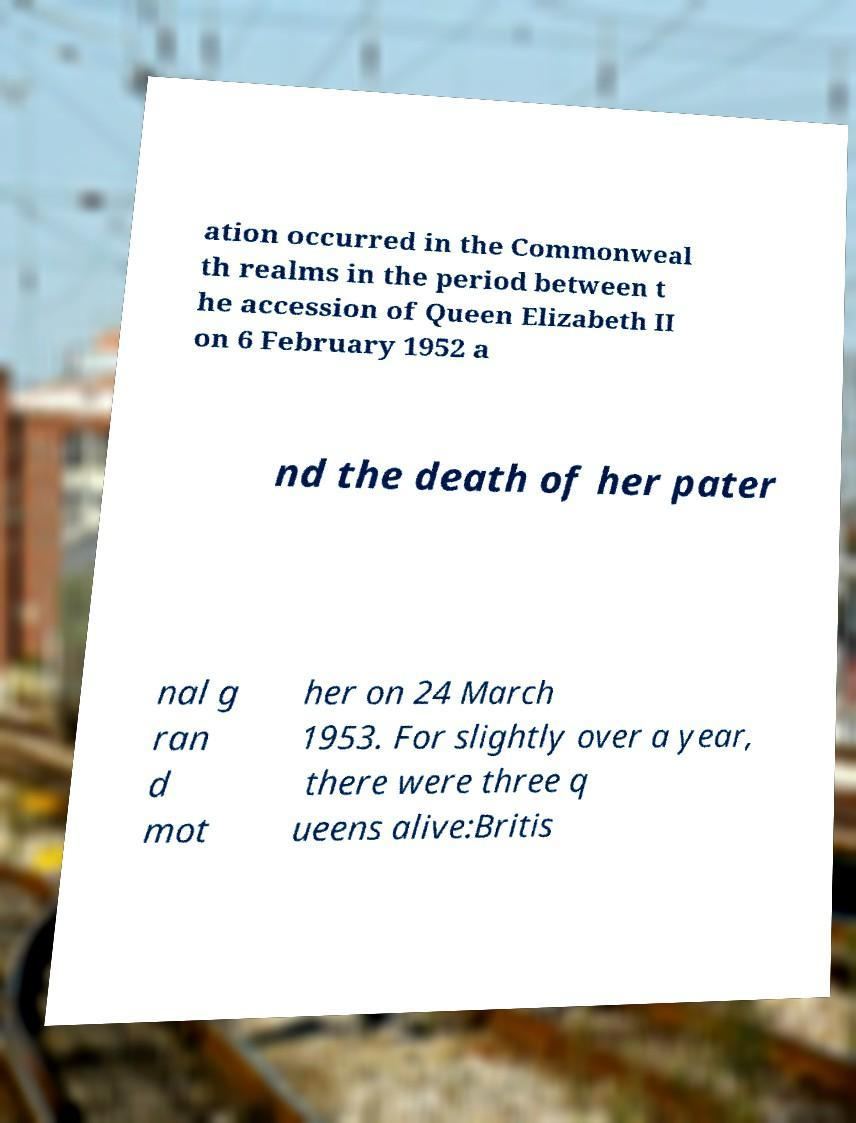Can you accurately transcribe the text from the provided image for me? ation occurred in the Commonweal th realms in the period between t he accession of Queen Elizabeth II on 6 February 1952 a nd the death of her pater nal g ran d mot her on 24 March 1953. For slightly over a year, there were three q ueens alive:Britis 